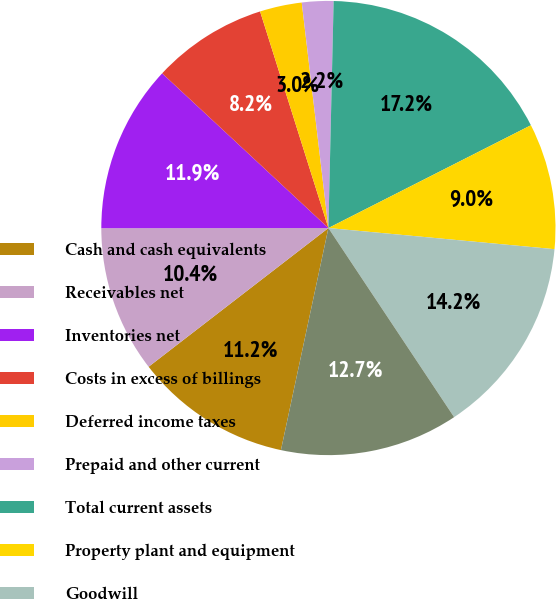<chart> <loc_0><loc_0><loc_500><loc_500><pie_chart><fcel>Cash and cash equivalents<fcel>Receivables net<fcel>Inventories net<fcel>Costs in excess of billings<fcel>Deferred income taxes<fcel>Prepaid and other current<fcel>Total current assets<fcel>Property plant and equipment<fcel>Goodwill<fcel>Intangibles net<nl><fcel>11.19%<fcel>10.45%<fcel>11.94%<fcel>8.21%<fcel>2.99%<fcel>2.24%<fcel>17.16%<fcel>8.96%<fcel>14.18%<fcel>12.69%<nl></chart> 